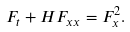<formula> <loc_0><loc_0><loc_500><loc_500>F _ { t } + H F _ { x x } = F _ { x } ^ { 2 } .</formula> 